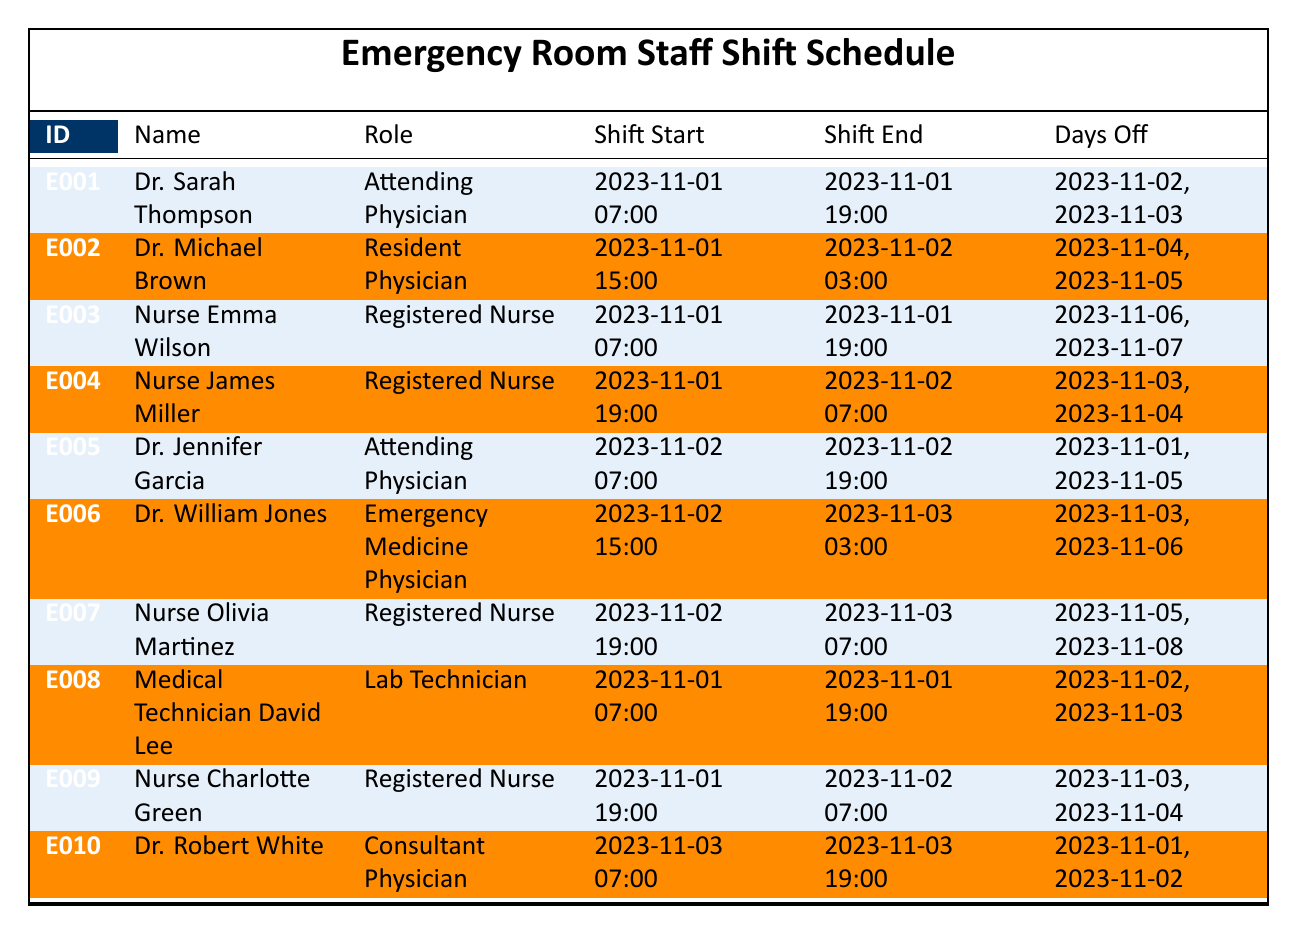What is the role of Dr. Sarah Thompson? The table lists Dr. Sarah Thompson's role in the "Role" column, which indicates she is an Attending Physician.
Answer: Attending Physician Who has days off on November 4th? To find this, we look for employees with "Days Off" that include the date November 4th. Dr. Michael Brown and Dr. William Jones have this date listed as a day off.
Answer: Dr. Michael Brown, Dr. William Jones Which nurse has the latest shift start time? By checking the "Shift Start" times for all nurses, Nurse Olivia Martinez starts at 19:00 on November 2nd, which is later than any other nurse's start time.
Answer: Nurse Olivia Martinez How many attending physicians are scheduled in this period? The table lists two attending physicians: Dr. Sarah Thompson and Dr. Jennifer Garcia. Thus, the count is two.
Answer: 2 Is Dr. Robert White scheduled to work on November 2nd? To confirm, we check the "Shift Start" and "Shift End" columns for Dr. Robert White; he only works on November 3rd. Therefore, he is not scheduled on November 2nd.
Answer: No How many total shifts are listed for nurses in the schedule? The table lists 5 nurses (Nurse Emma Wilson, Nurse James Miller, Nurse Olivia Martinez, Nurse Charlotte Green) and each has one shift; hence, there are 5 shifts in total for nurses.
Answer: 5 What is the time duration of Dr. Michael Brown's shift on November 1st? Dr. Michael Brown's shift starts at 15:00 on November 1st and ends at 03:00 on November 2nd. The duration is 12 hours, from 15:00 to 03:00.
Answer: 12 hours Which employee has the longest continuous shift? Evaluating the lengths of shifts, Dr. Michael Brown's shift is continuous from 15:00 to 03:00 (12 hours), which is the longest in this table.
Answer: Dr. Michael Brown Which two employees work back-to-back shifts on November 1st? Dr. Sarah Thompson works from 07:00 to 19:00, and Nurse James Miller works later from 19:00 to 07:00 the next day, creating a back-to-back shift situation.
Answer: Dr. Sarah Thompson, Nurse James Miller 